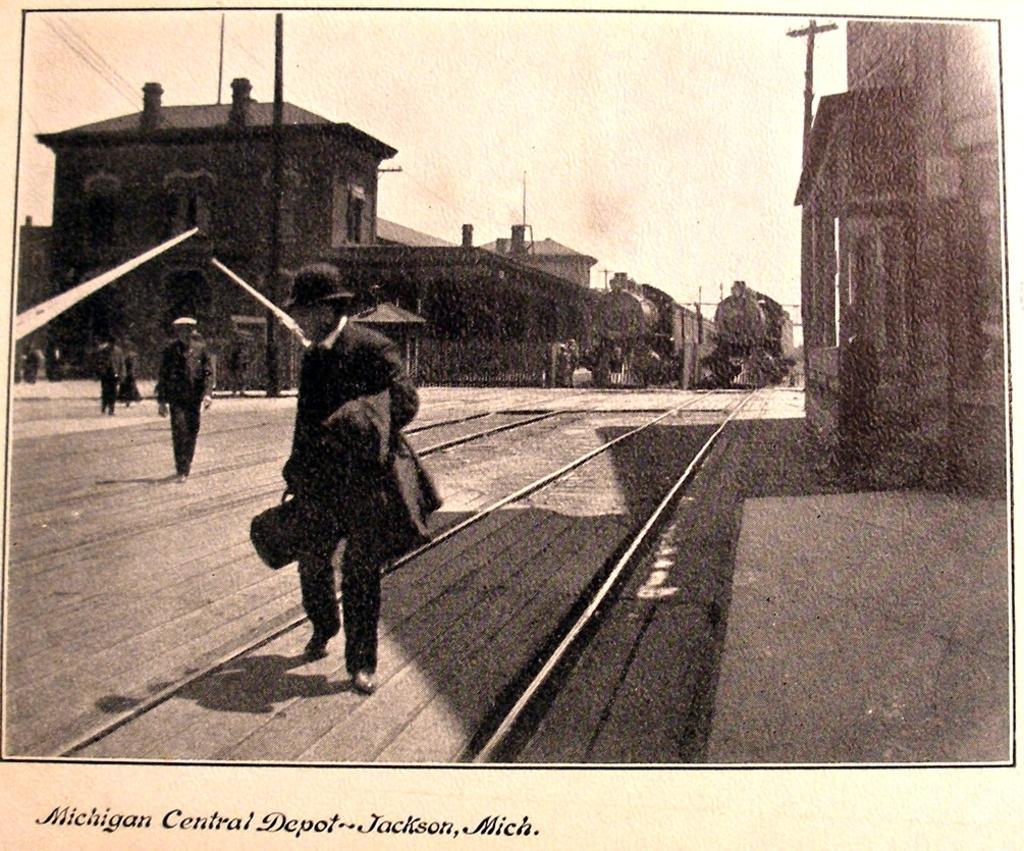Describe this image in one or two sentences. In this picture I can see there is a man walking, he is wearing a cap, holding a bag. There is another person in the backdrop and there are two trains and there is a building at the right and left side. The sky is clear. 